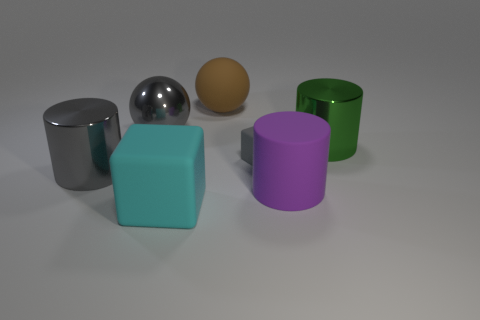How many other things are the same color as the rubber cylinder?
Offer a very short reply. 0. How many yellow objects are either big shiny cylinders or large balls?
Your response must be concise. 0. Do the large rubber thing that is right of the big rubber ball and the large thing that is right of the purple rubber thing have the same shape?
Offer a very short reply. Yes. How many other objects are the same material as the large purple cylinder?
Give a very brief answer. 3. There is a metallic object right of the matte block that is on the right side of the big brown rubber thing; is there a big metal object on the right side of it?
Ensure brevity in your answer.  No. Does the purple object have the same material as the brown thing?
Your answer should be very brief. Yes. Is there any other thing that is the same shape as the green metallic object?
Make the answer very short. Yes. What is the big green cylinder in front of the brown rubber object that is left of the tiny gray block made of?
Keep it short and to the point. Metal. What is the size of the cylinder that is left of the large brown thing?
Your response must be concise. Large. What is the color of the large rubber thing that is both left of the large purple matte object and to the right of the large cyan rubber object?
Your response must be concise. Brown. 